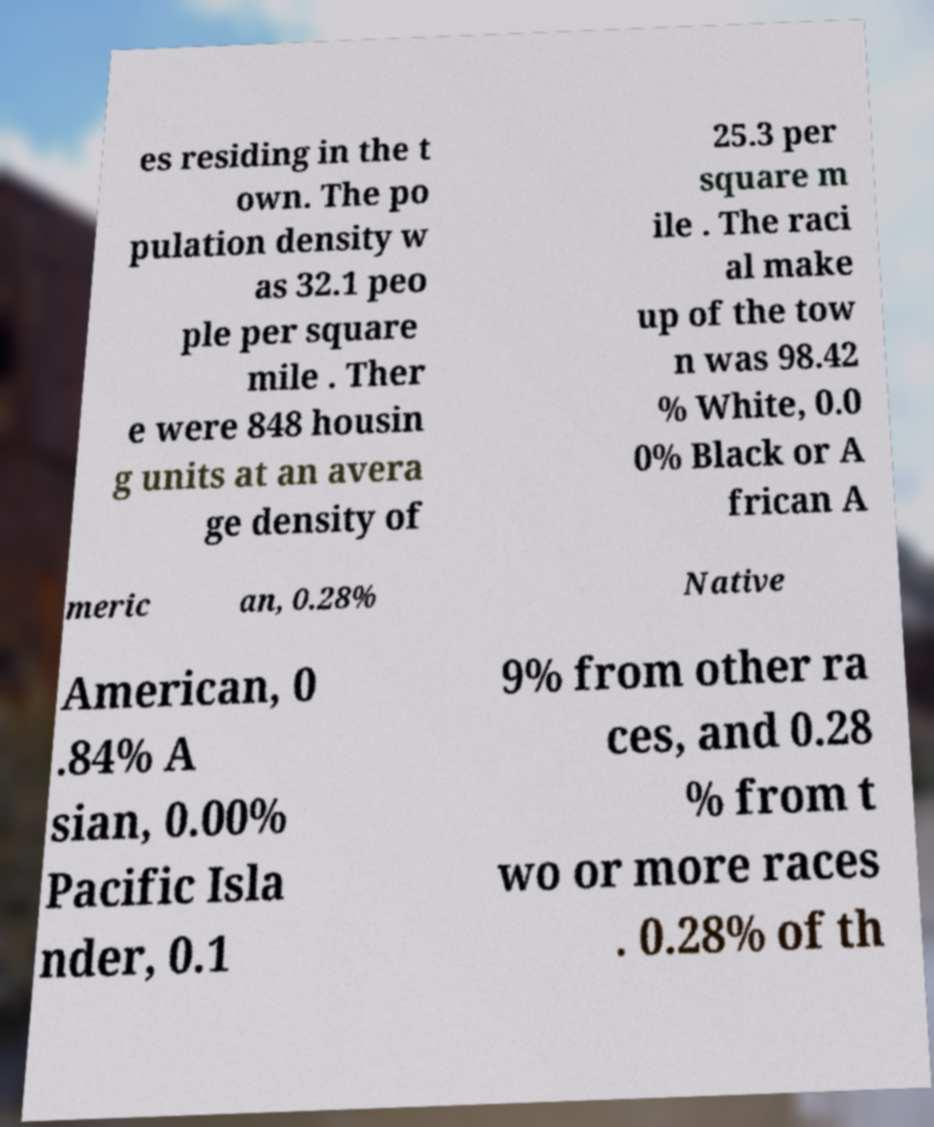Please identify and transcribe the text found in this image. es residing in the t own. The po pulation density w as 32.1 peo ple per square mile . Ther e were 848 housin g units at an avera ge density of 25.3 per square m ile . The raci al make up of the tow n was 98.42 % White, 0.0 0% Black or A frican A meric an, 0.28% Native American, 0 .84% A sian, 0.00% Pacific Isla nder, 0.1 9% from other ra ces, and 0.28 % from t wo or more races . 0.28% of th 